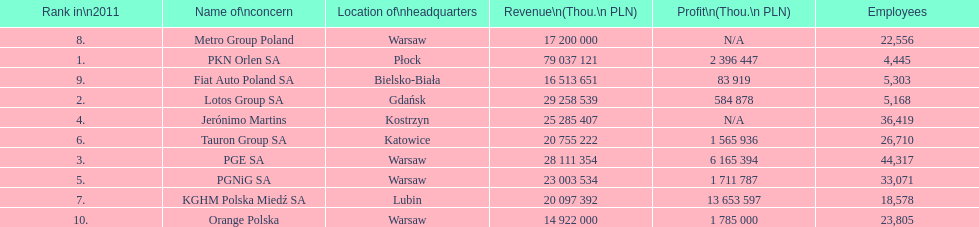What company has the top number of employees? PGE SA. 